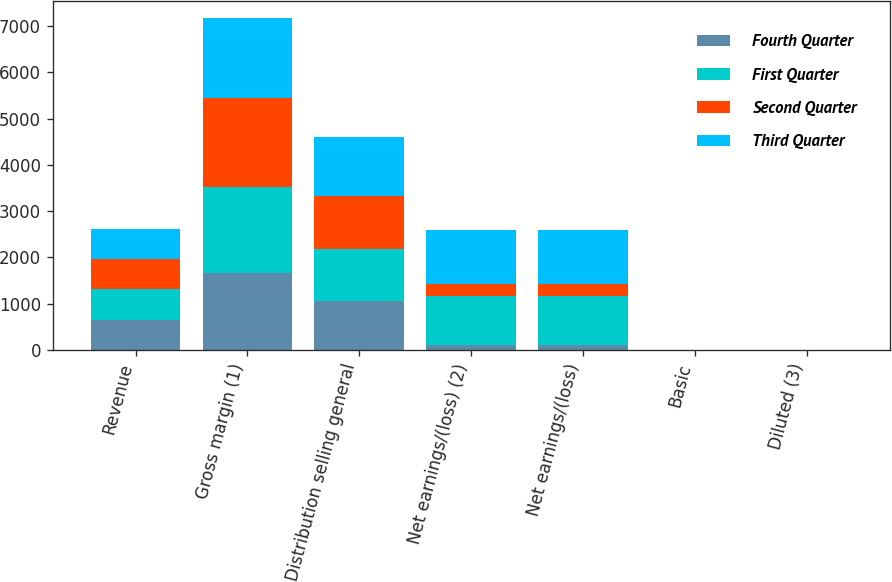<chart> <loc_0><loc_0><loc_500><loc_500><stacked_bar_chart><ecel><fcel>Revenue<fcel>Gross margin (1)<fcel>Distribution selling general<fcel>Net earnings/(loss) (2)<fcel>Net earnings/(loss)<fcel>Basic<fcel>Diluted (3)<nl><fcel>Fourth Quarter<fcel>654<fcel>1672<fcel>1062<fcel>117<fcel>115<fcel>0.36<fcel>0.36<nl><fcel>First Quarter<fcel>654<fcel>1861<fcel>1131<fcel>1053<fcel>1053<fcel>3.35<fcel>3.33<nl><fcel>Second Quarter<fcel>654<fcel>1913<fcel>1132<fcel>255<fcel>255<fcel>0.81<fcel>0.81<nl><fcel>Third Quarter<fcel>654<fcel>1735<fcel>1270<fcel>1166<fcel>1166<fcel>3.76<fcel>3.76<nl></chart> 